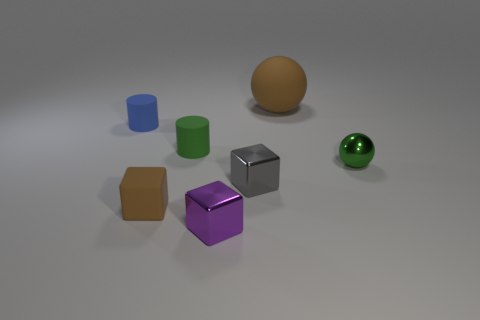What time of day does the lighting suggest in this scene? The neutral and soft shadowing in the scene suggests an indoor environment with controlled lighting, possibly simulating daylight but without a specific time of day associated. 